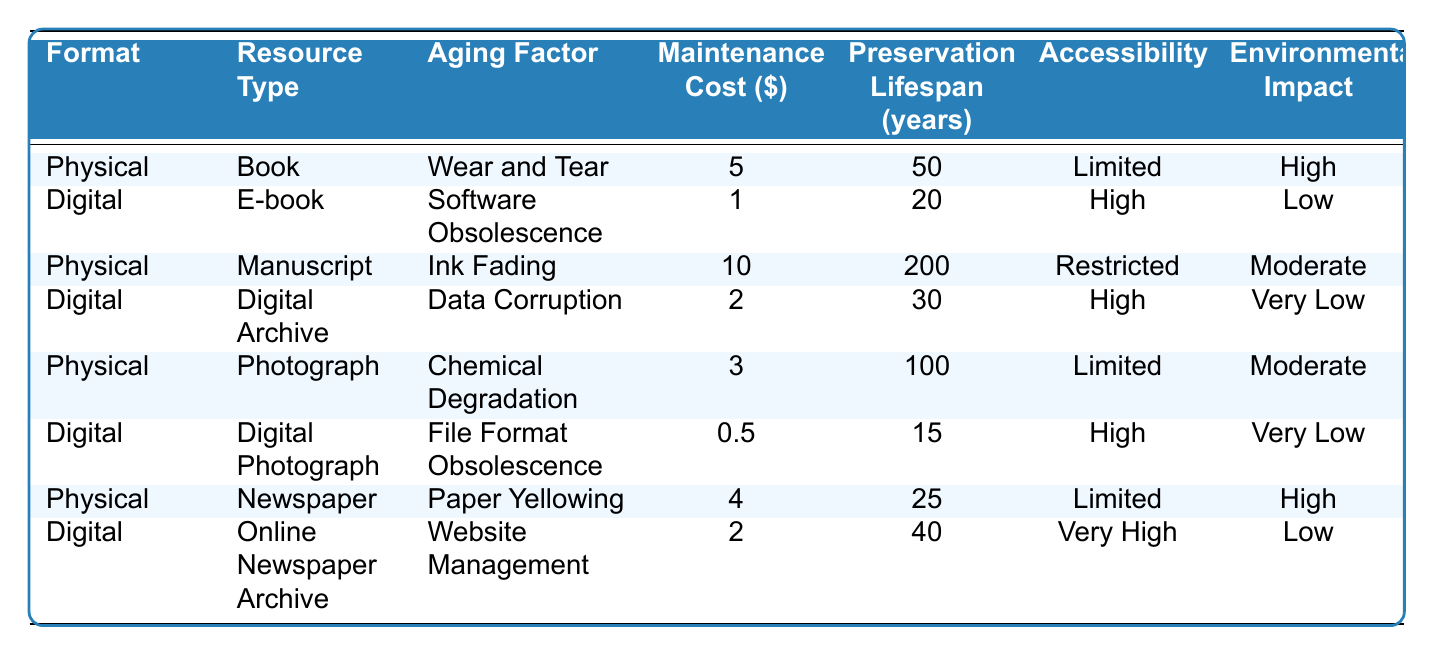What is the maintenance cost for a physical book? From the table, the maintenance cost for a physical book is listed directly in the corresponding row, which shows a cost of $5.
Answer: $5 How many years is the preservation lifespan of a manuscript? The preservation lifespan for a manuscript is specified in the table's relevant row, which indicates it is 200 years.
Answer: 200 years Which format has a higher accessibility, physical resources or digital resources? By comparing the accessibility values in the rows, digital formats like E-book and Digital Archive show "High" or "Very High," while physical formats like Book and Photograph show "Limited." Thus, digital resources have higher accessibility.
Answer: Digital resources What is the average maintenance cost for physical formats? The maintenance costs for physical formats in the table are $5 (Book), $10 (Manuscript), $3 (Photograph), and $4 (Newspaper). Calculating the average: (5 + 10 + 3 + 4) / 4 = 22 / 4 = 5.5.
Answer: $5.5 Is the environmental impact of digital photographs higher than that of physical photographs? The environmental impact for Digital Photograph is noted as "Very Low" and for Physical Photograph as "Moderate." Since "Very Low" is less impactful than "Moderate," the statement is false.
Answer: No How does the preservation lifespan of digital archives compare to that of e-books? The preservation lifespan for Digital Archive is 30 years and for E-book is 20 years. Since 30 is greater than 20, Digital Archive has a longer lifespan than E-book.
Answer: Longer What is the total maintenance cost for all resources in the table? Summing the maintenance costs: 5 (Book) + 1 (E-book) + 10 (Manuscript) + 2 (Digital Archive) + 3 (Photograph) + 0.5 (Digital Photograph) + 4 (Newspaper) + 2 (Online Newspaper Archive) = 27.5.
Answer: $27.5 How many resources have a "Limited" accessibility rating? By examining the rows for resources with "Limited" accessibility, we find 3 instances: Book, Photograph, and Newspaper. Thus, there are 3 resources.
Answer: 3 What is the difference in preservation lifespan between a manuscript and an online newspaper archive? The preservation lifespan of a manuscript is 200 years and for an online newspaper archive, it is 40 years. The difference is 200 - 40 = 160 years.
Answer: 160 years Do any digital formats have maintenance costs lower than $1? By inspecting the table, only Digital Photograph has a maintenance cost of $0.5, which is lower than $1.
Answer: Yes 